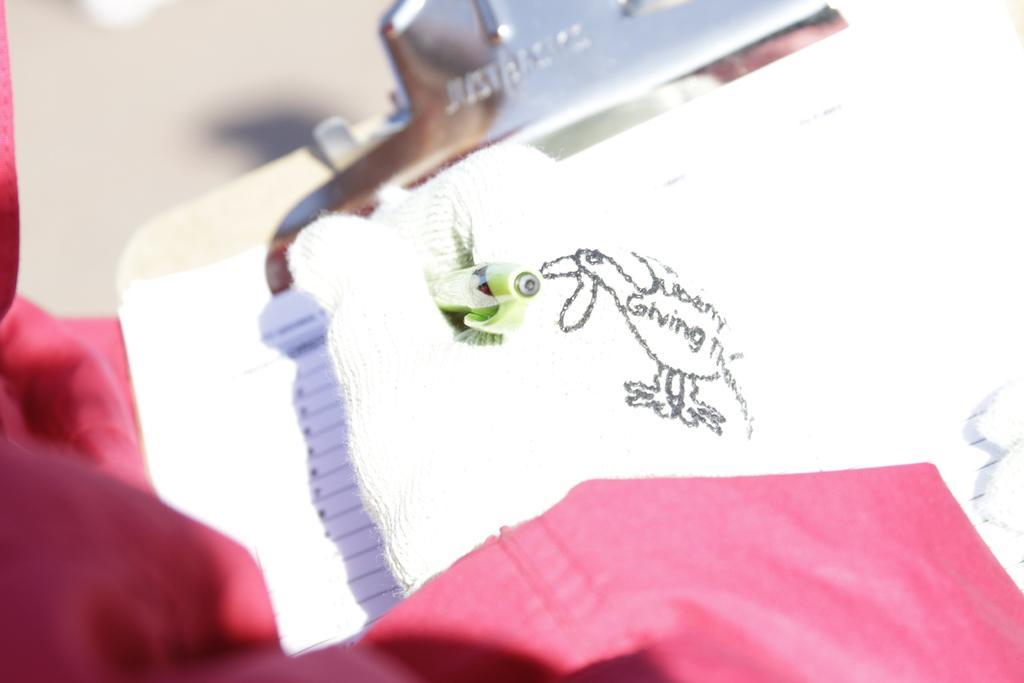Could you give a brief overview of what you see in this image? In this picture we can see a paper on the pad, and we can find a red color cloth. 